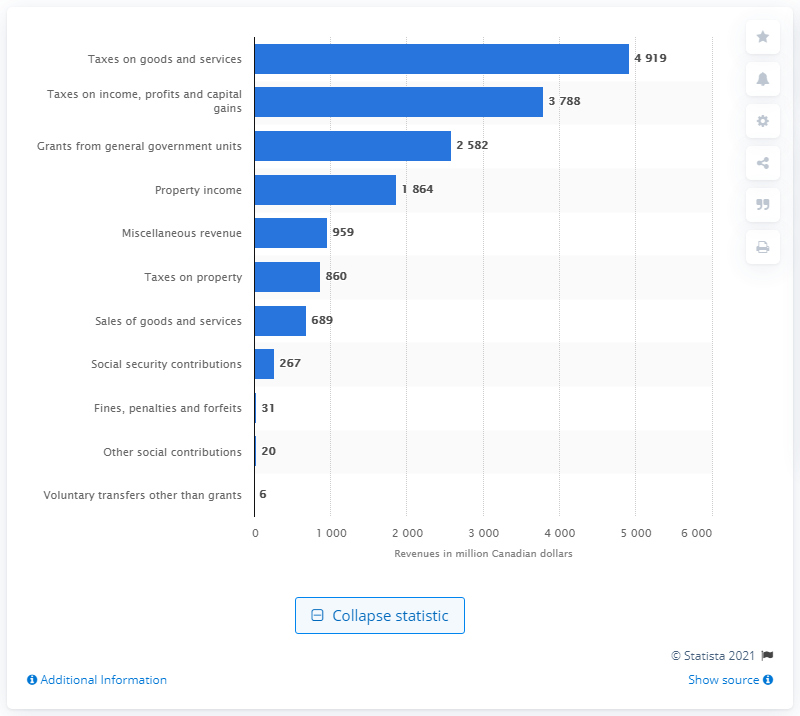Highlight a few significant elements in this photo. In 2019, the Saskatchewan government collected a total of CAD 4,919 through taxes on goods and services. 